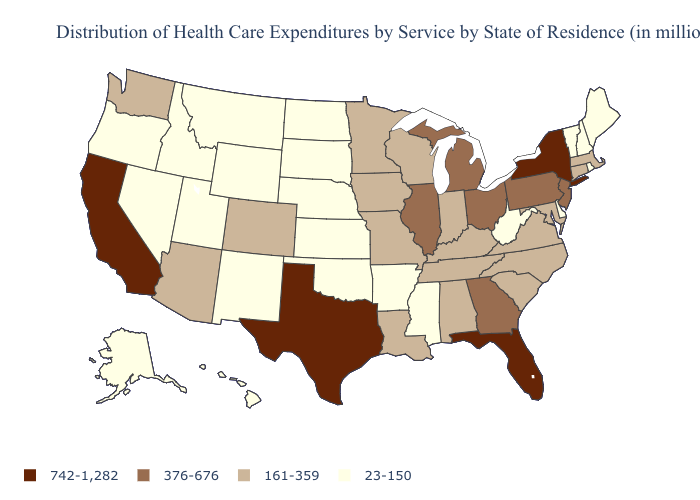What is the highest value in states that border Iowa?
Answer briefly. 376-676. Does the first symbol in the legend represent the smallest category?
Quick response, please. No. What is the highest value in the West ?
Keep it brief. 742-1,282. Does the first symbol in the legend represent the smallest category?
Short answer required. No. What is the value of South Carolina?
Quick response, please. 161-359. Which states hav the highest value in the West?
Be succinct. California. Does Maryland have a higher value than Ohio?
Write a very short answer. No. What is the lowest value in states that border Delaware?
Answer briefly. 161-359. Name the states that have a value in the range 23-150?
Short answer required. Alaska, Arkansas, Delaware, Hawaii, Idaho, Kansas, Maine, Mississippi, Montana, Nebraska, Nevada, New Hampshire, New Mexico, North Dakota, Oklahoma, Oregon, Rhode Island, South Dakota, Utah, Vermont, West Virginia, Wyoming. Name the states that have a value in the range 742-1,282?
Keep it brief. California, Florida, New York, Texas. Among the states that border Idaho , which have the highest value?
Answer briefly. Washington. Name the states that have a value in the range 742-1,282?
Answer briefly. California, Florida, New York, Texas. Name the states that have a value in the range 161-359?
Quick response, please. Alabama, Arizona, Colorado, Connecticut, Indiana, Iowa, Kentucky, Louisiana, Maryland, Massachusetts, Minnesota, Missouri, North Carolina, South Carolina, Tennessee, Virginia, Washington, Wisconsin. What is the value of Massachusetts?
Keep it brief. 161-359. Name the states that have a value in the range 23-150?
Answer briefly. Alaska, Arkansas, Delaware, Hawaii, Idaho, Kansas, Maine, Mississippi, Montana, Nebraska, Nevada, New Hampshire, New Mexico, North Dakota, Oklahoma, Oregon, Rhode Island, South Dakota, Utah, Vermont, West Virginia, Wyoming. 